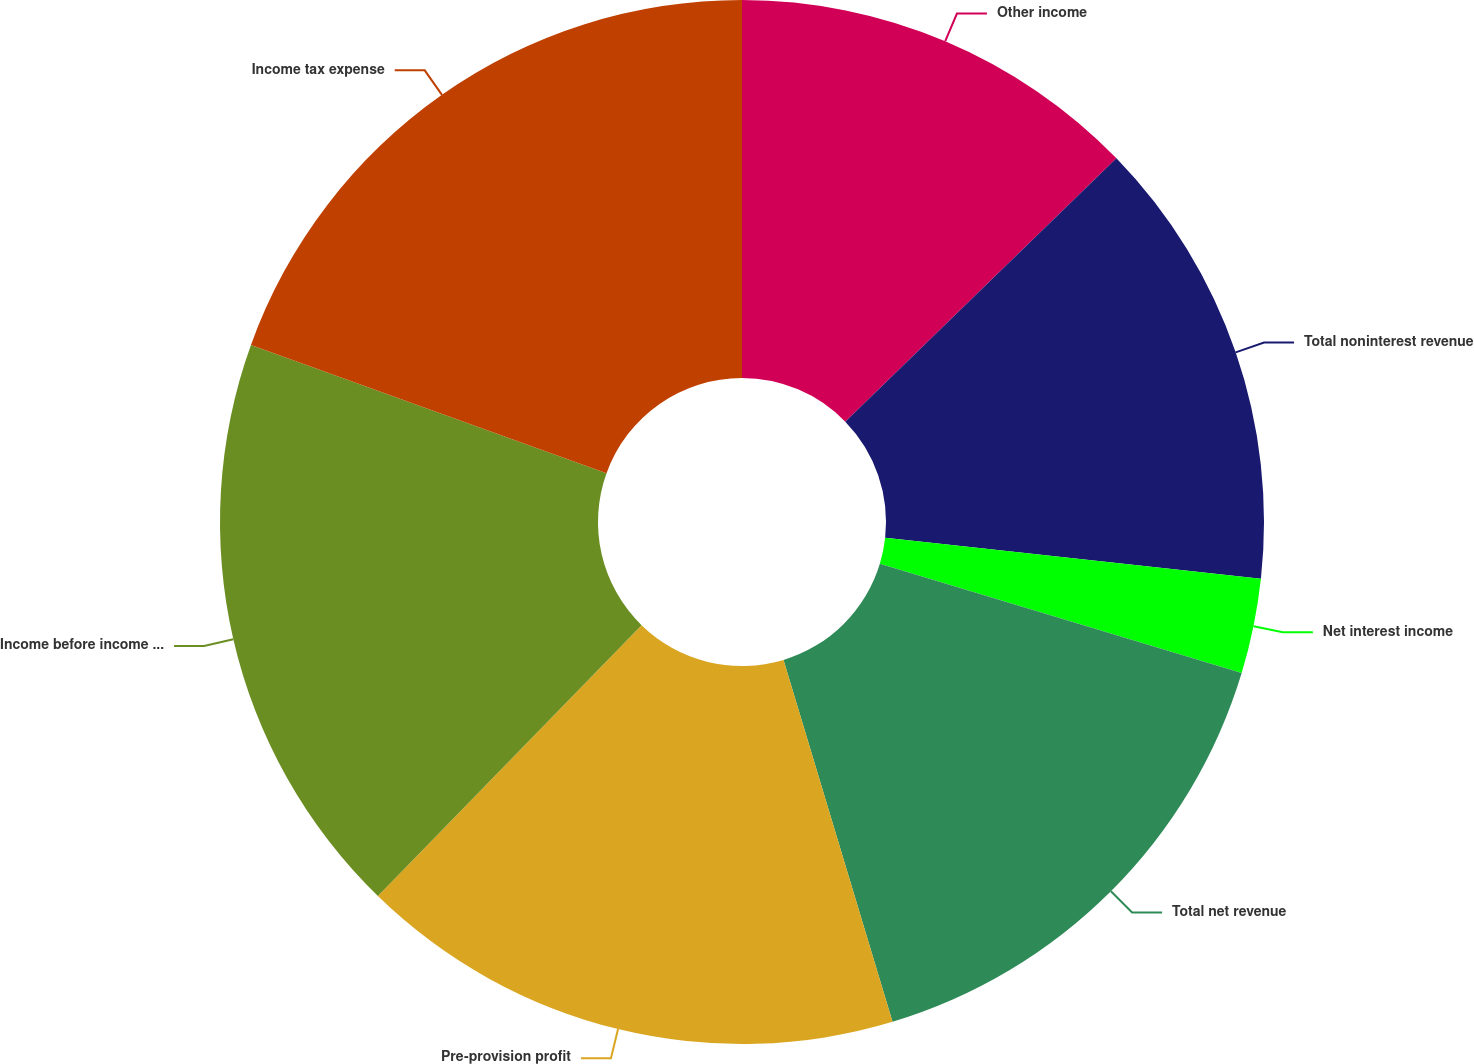<chart> <loc_0><loc_0><loc_500><loc_500><pie_chart><fcel>Other income<fcel>Total noninterest revenue<fcel>Net interest income<fcel>Total net revenue<fcel>Pre-provision profit<fcel>Income before income tax<fcel>Income tax expense<nl><fcel>12.73%<fcel>14.0%<fcel>2.94%<fcel>15.67%<fcel>16.94%<fcel>18.22%<fcel>19.49%<nl></chart> 